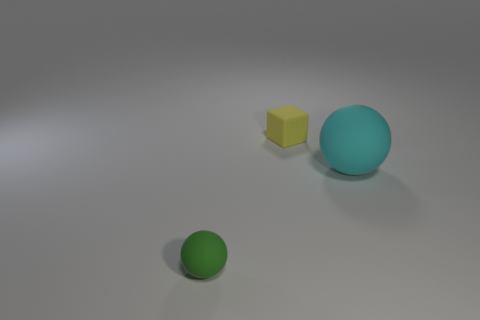Are there any other green matte things that have the same size as the green rubber object?
Offer a terse response. No. How big is the yellow cube?
Ensure brevity in your answer.  Small. What number of yellow matte things are the same size as the block?
Keep it short and to the point. 0. Is the number of big rubber objects left of the big matte ball less than the number of small yellow things that are left of the tiny yellow rubber block?
Your answer should be compact. No. There is a sphere that is behind the ball that is left of the rubber ball behind the tiny green rubber ball; what size is it?
Offer a terse response. Large. What size is the matte thing that is both behind the green sphere and to the left of the cyan ball?
Provide a short and direct response. Small. There is a object that is behind the matte ball to the right of the tiny yellow rubber cube; what shape is it?
Ensure brevity in your answer.  Cube. Are there any other things of the same color as the tiny sphere?
Give a very brief answer. No. There is a thing that is behind the big rubber sphere; what shape is it?
Make the answer very short. Cube. There is a thing that is on the left side of the large cyan matte thing and right of the small matte ball; what shape is it?
Ensure brevity in your answer.  Cube. 